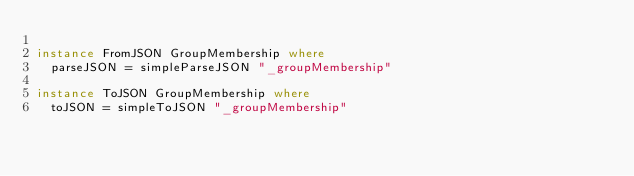Convert code to text. <code><loc_0><loc_0><loc_500><loc_500><_Haskell_>
instance FromJSON GroupMembership where
  parseJSON = simpleParseJSON "_groupMembership"

instance ToJSON GroupMembership where
  toJSON = simpleToJSON "_groupMembership"
</code> 